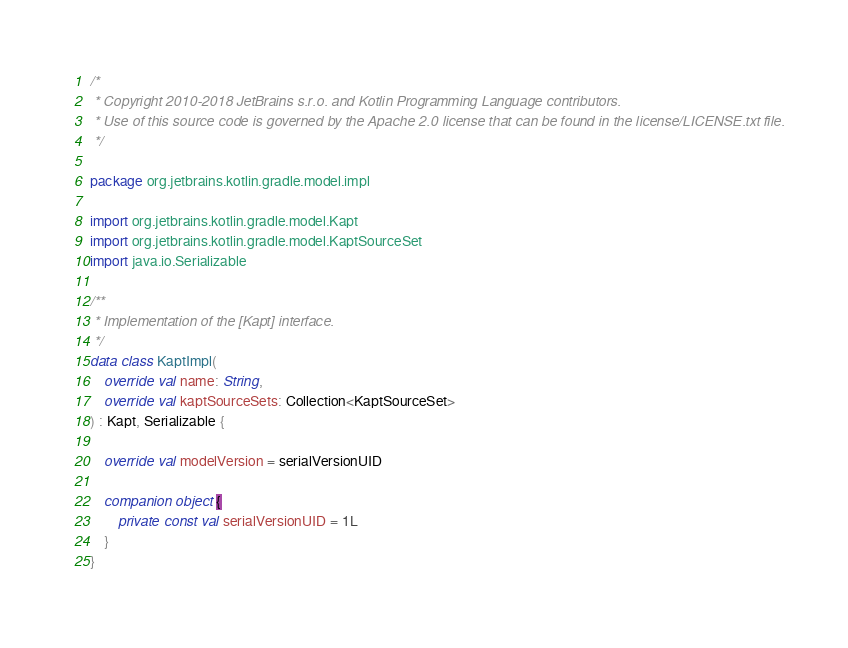Convert code to text. <code><loc_0><loc_0><loc_500><loc_500><_Kotlin_>/*
 * Copyright 2010-2018 JetBrains s.r.o. and Kotlin Programming Language contributors.
 * Use of this source code is governed by the Apache 2.0 license that can be found in the license/LICENSE.txt file.
 */

package org.jetbrains.kotlin.gradle.model.impl

import org.jetbrains.kotlin.gradle.model.Kapt
import org.jetbrains.kotlin.gradle.model.KaptSourceSet
import java.io.Serializable

/**
 * Implementation of the [Kapt] interface.
 */
data class KaptImpl(
    override val name: String,
    override val kaptSourceSets: Collection<KaptSourceSet>
) : Kapt, Serializable {

    override val modelVersion = serialVersionUID

    companion object {
        private const val serialVersionUID = 1L
    }
}</code> 